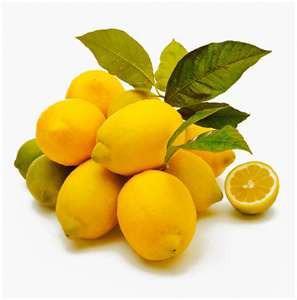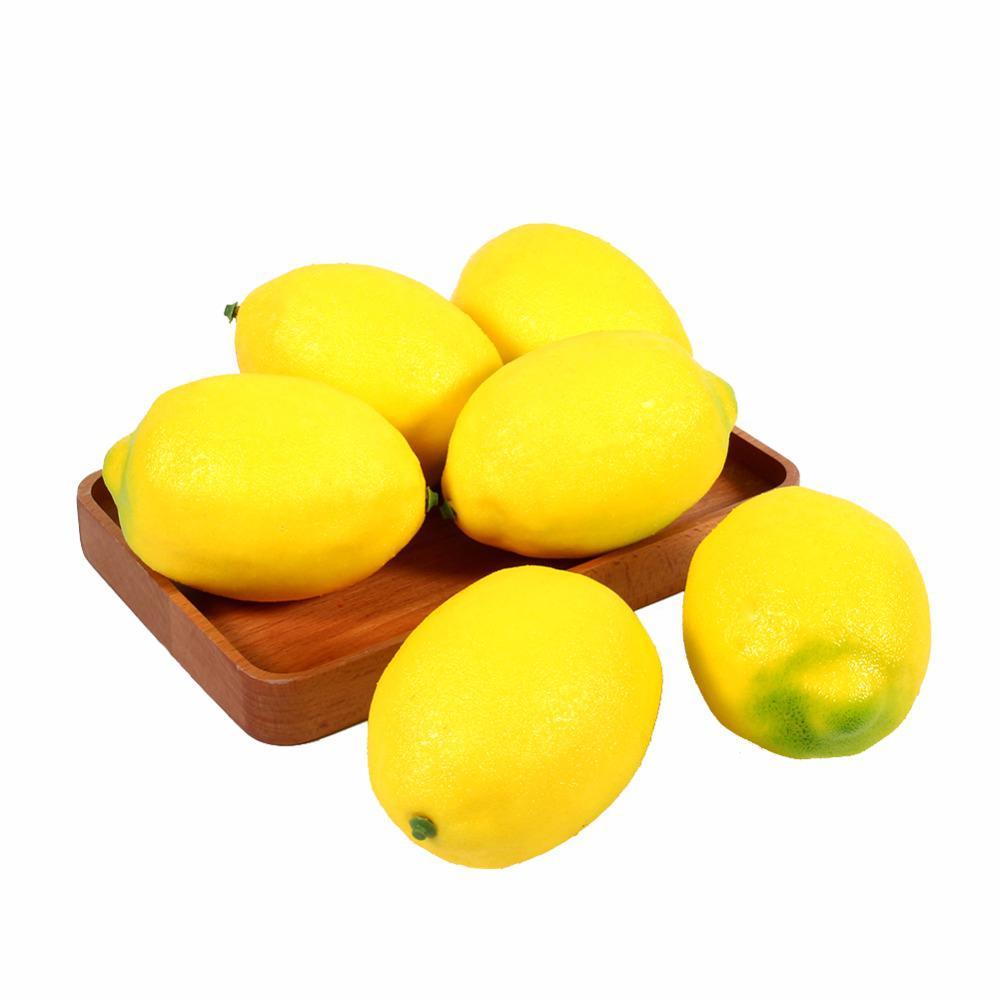The first image is the image on the left, the second image is the image on the right. Assess this claim about the two images: "The combined images include exactly one cut half lemon and at least eleven whole citrus fruits.". Correct or not? Answer yes or no. Yes. The first image is the image on the left, the second image is the image on the right. Given the left and right images, does the statement "There is a sliced lemon in exactly one image." hold true? Answer yes or no. Yes. 